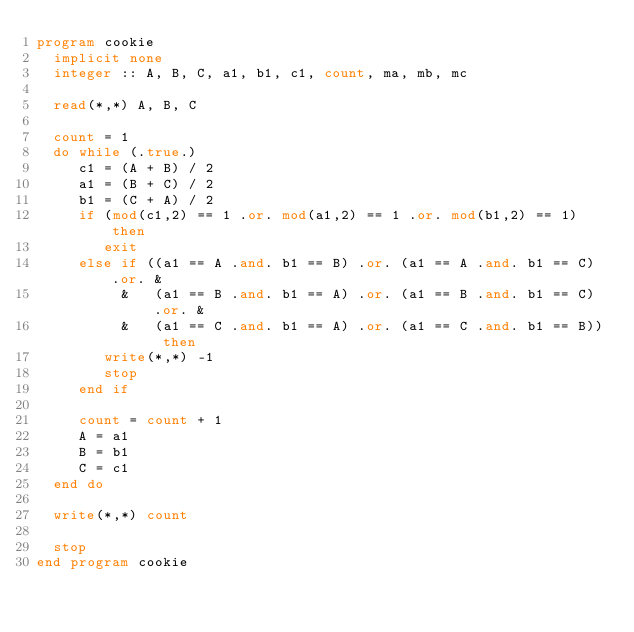<code> <loc_0><loc_0><loc_500><loc_500><_FORTRAN_>program cookie
  implicit none
  integer :: A, B, C, a1, b1, c1, count, ma, mb, mc
  
  read(*,*) A, B, C
  
  count = 1
  do while (.true.)
     c1 = (A + B) / 2
     a1 = (B + C) / 2
     b1 = (C + A) / 2
     if (mod(c1,2) == 1 .or. mod(a1,2) == 1 .or. mod(b1,2) == 1) then
        exit
     else if ((a1 == A .and. b1 == B) .or. (a1 == A .and. b1 == C) .or. &
          &   (a1 == B .and. b1 == A) .or. (a1 == B .and. b1 == C) .or. &
          &   (a1 == C .and. b1 == A) .or. (a1 == C .and. b1 == B)) then
        write(*,*) -1
        stop
     end if
        
     count = count + 1
     A = a1
     B = b1
     C = c1
  end do

  write(*,*) count
  
  stop
end program cookie
</code> 